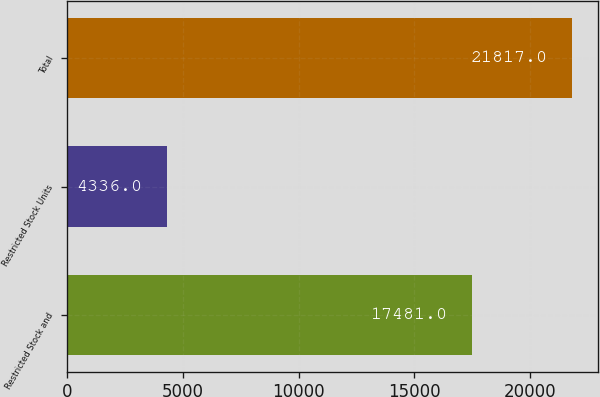Convert chart to OTSL. <chart><loc_0><loc_0><loc_500><loc_500><bar_chart><fcel>Restricted Stock and<fcel>Restricted Stock Units<fcel>Total<nl><fcel>17481<fcel>4336<fcel>21817<nl></chart> 